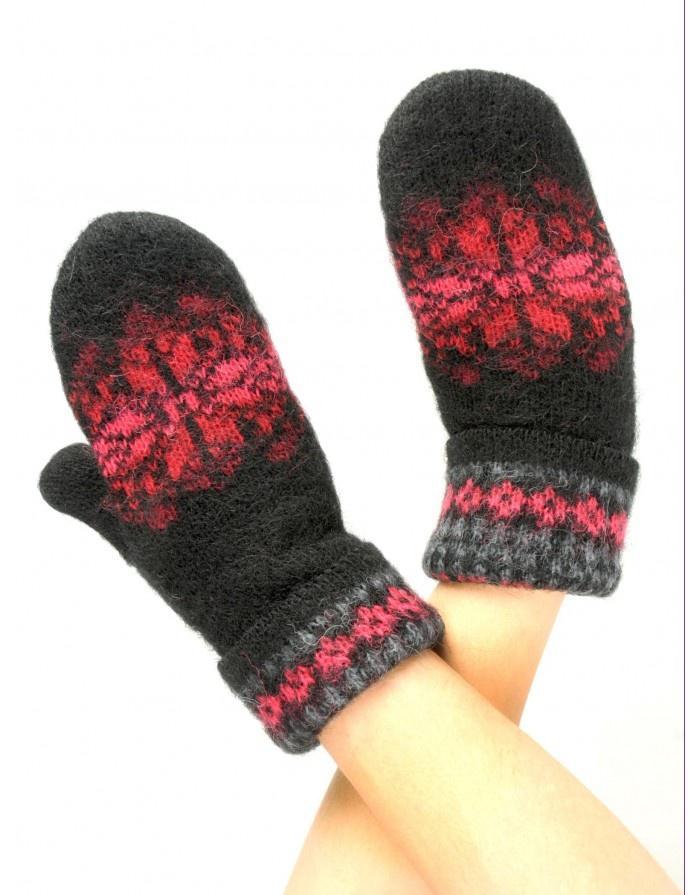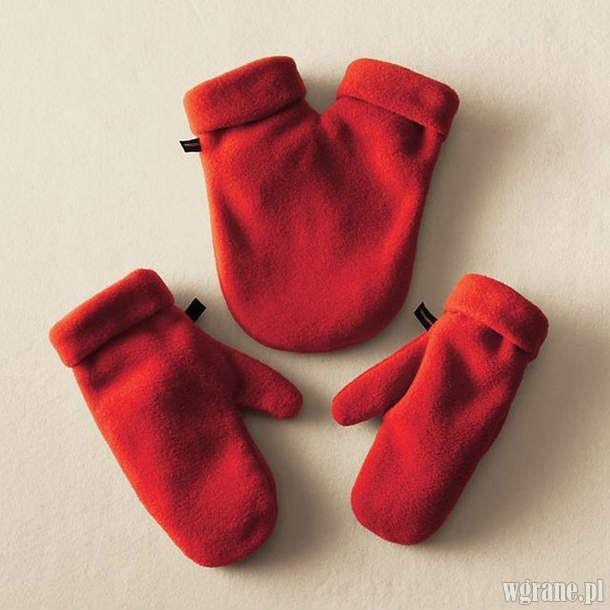The first image is the image on the left, the second image is the image on the right. Analyze the images presented: Is the assertion "All of the mittens in the image on the right are red." valid? Answer yes or no. Yes. The first image is the image on the left, the second image is the image on the right. Given the left and right images, does the statement "The right image shows solid red mittens with a joined 'muff' between them." hold true? Answer yes or no. Yes. 